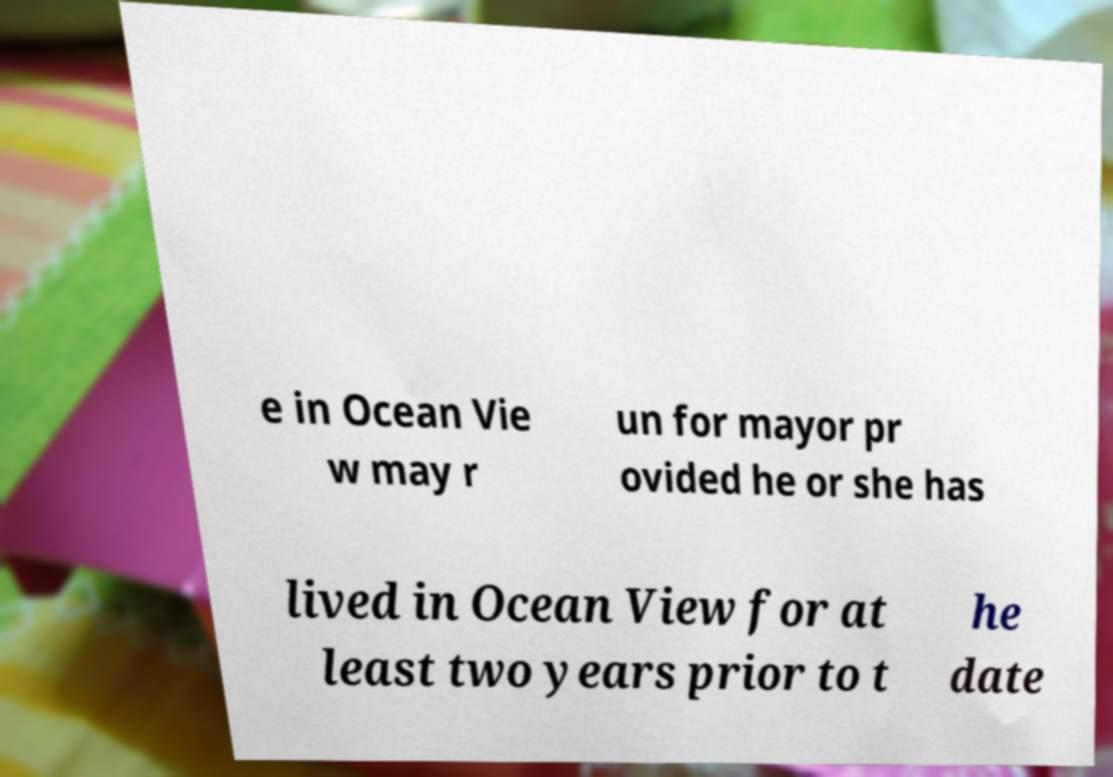Could you extract and type out the text from this image? e in Ocean Vie w may r un for mayor pr ovided he or she has lived in Ocean View for at least two years prior to t he date 